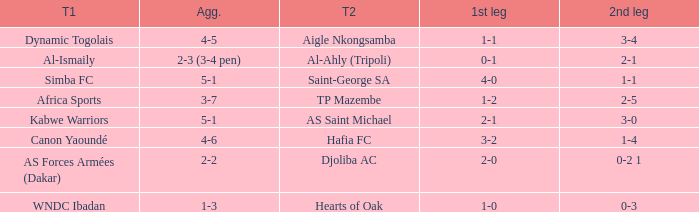What team played against Al-Ismaily (team 1)? Al-Ahly (Tripoli). Parse the table in full. {'header': ['T1', 'Agg.', 'T2', '1st leg', '2nd leg'], 'rows': [['Dynamic Togolais', '4-5', 'Aigle Nkongsamba', '1-1', '3-4'], ['Al-Ismaily', '2-3 (3-4 pen)', 'Al-Ahly (Tripoli)', '0-1', '2-1'], ['Simba FC', '5-1', 'Saint-George SA', '4-0', '1-1'], ['Africa Sports', '3-7', 'TP Mazembe', '1-2', '2-5'], ['Kabwe Warriors', '5-1', 'AS Saint Michael', '2-1', '3-0'], ['Canon Yaoundé', '4-6', 'Hafia FC', '3-2', '1-4'], ['AS Forces Armées (Dakar)', '2-2', 'Djoliba AC', '2-0', '0-2 1'], ['WNDC Ibadan', '1-3', 'Hearts of Oak', '1-0', '0-3']]} 